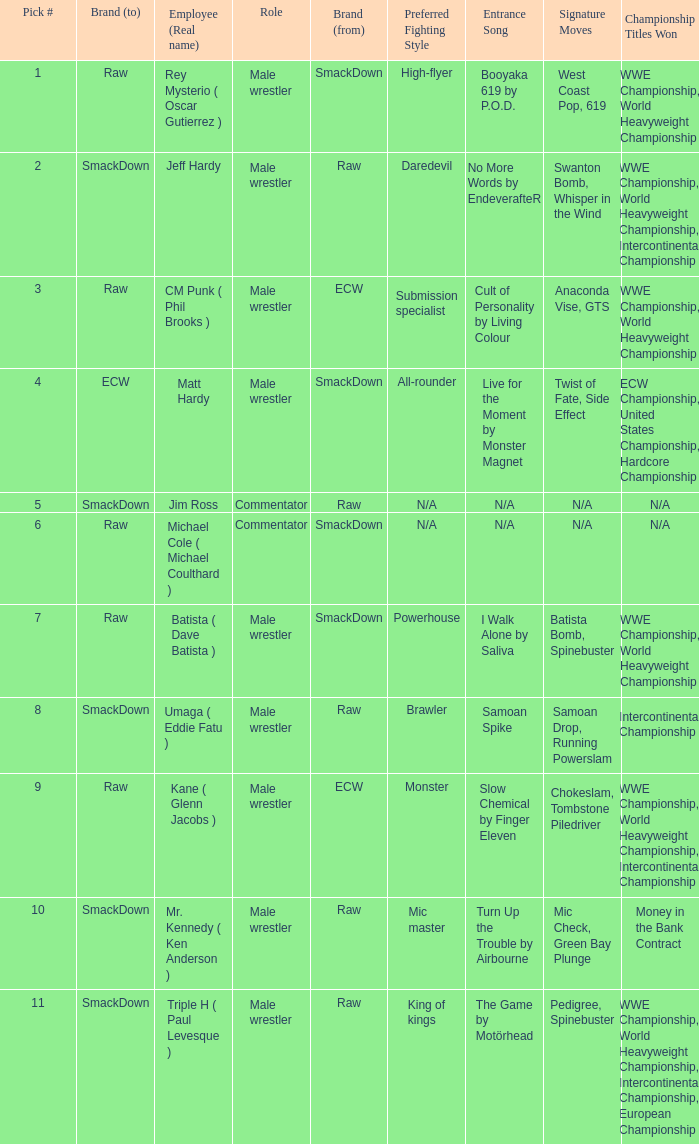What role did Pick # 10 have? Male wrestler. 